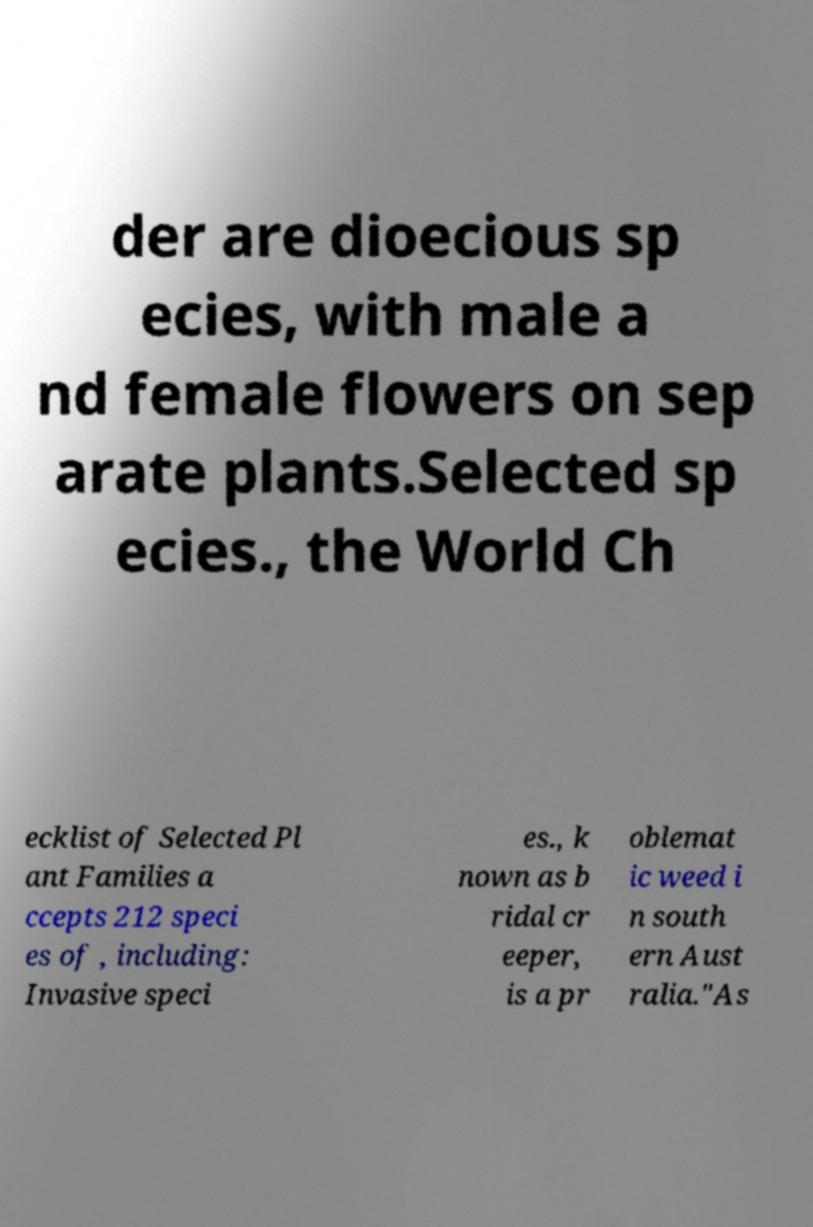Could you assist in decoding the text presented in this image and type it out clearly? der are dioecious sp ecies, with male a nd female flowers on sep arate plants.Selected sp ecies., the World Ch ecklist of Selected Pl ant Families a ccepts 212 speci es of , including: Invasive speci es., k nown as b ridal cr eeper, is a pr oblemat ic weed i n south ern Aust ralia."As 